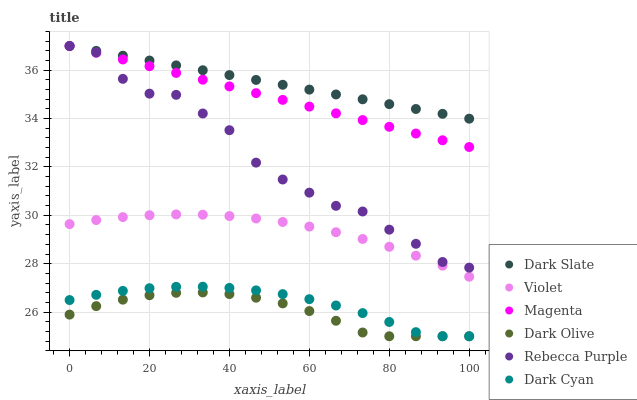Does Dark Olive have the minimum area under the curve?
Answer yes or no. Yes. Does Dark Slate have the maximum area under the curve?
Answer yes or no. Yes. Does Rebecca Purple have the minimum area under the curve?
Answer yes or no. No. Does Rebecca Purple have the maximum area under the curve?
Answer yes or no. No. Is Dark Slate the smoothest?
Answer yes or no. Yes. Is Rebecca Purple the roughest?
Answer yes or no. Yes. Is Rebecca Purple the smoothest?
Answer yes or no. No. Is Dark Slate the roughest?
Answer yes or no. No. Does Dark Olive have the lowest value?
Answer yes or no. Yes. Does Rebecca Purple have the lowest value?
Answer yes or no. No. Does Magenta have the highest value?
Answer yes or no. Yes. Does Violet have the highest value?
Answer yes or no. No. Is Dark Olive less than Dark Slate?
Answer yes or no. Yes. Is Dark Slate greater than Violet?
Answer yes or no. Yes. Does Magenta intersect Dark Slate?
Answer yes or no. Yes. Is Magenta less than Dark Slate?
Answer yes or no. No. Is Magenta greater than Dark Slate?
Answer yes or no. No. Does Dark Olive intersect Dark Slate?
Answer yes or no. No. 